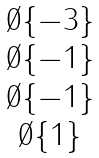Convert formula to latex. <formula><loc_0><loc_0><loc_500><loc_500>\begin{matrix} \emptyset \{ - 3 \} \\ \emptyset \{ - 1 \} \\ \emptyset \{ - 1 \} \\ \emptyset \{ 1 \} \end{matrix}</formula> 